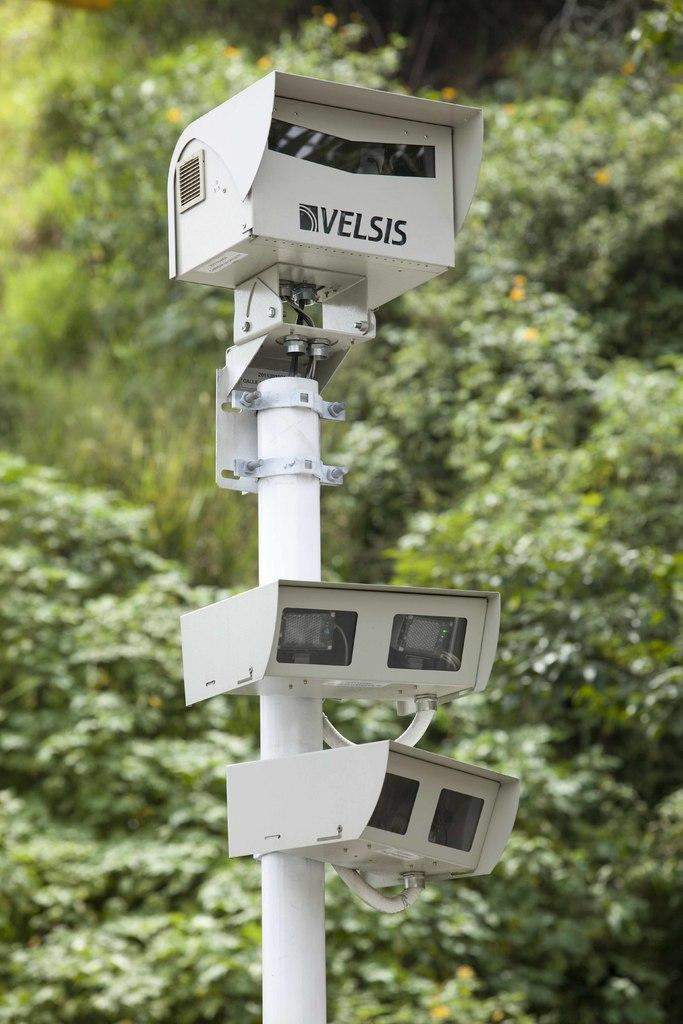What objects are present in the image? There are cameras and a metal rod in the image. What type of natural elements can be seen in the image? There are trees in the image. What type of yak can be seen grazing near the cameras in the image? There is no yak present in the image; it only features cameras, a metal rod, and trees. 